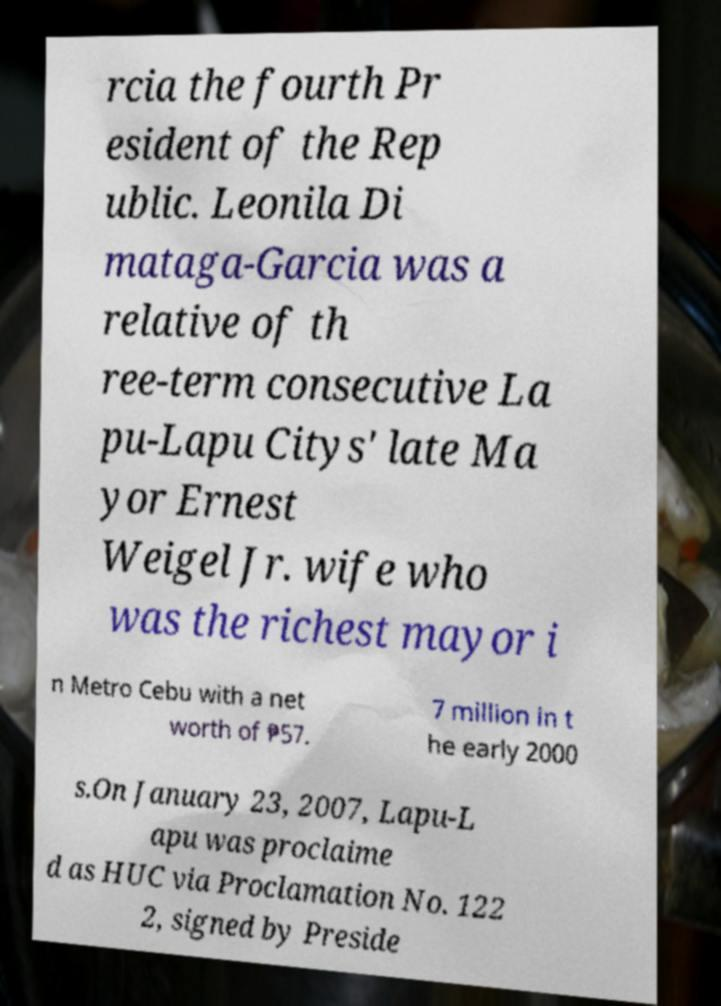I need the written content from this picture converted into text. Can you do that? rcia the fourth Pr esident of the Rep ublic. Leonila Di mataga-Garcia was a relative of th ree-term consecutive La pu-Lapu Citys' late Ma yor Ernest Weigel Jr. wife who was the richest mayor i n Metro Cebu with a net worth of ₱57. 7 million in t he early 2000 s.On January 23, 2007, Lapu-L apu was proclaime d as HUC via Proclamation No. 122 2, signed by Preside 